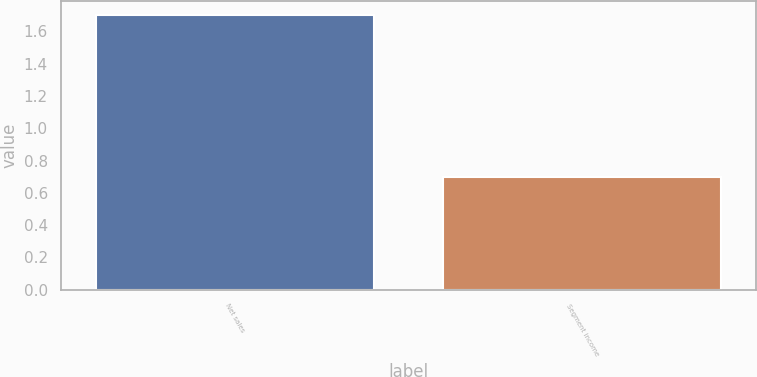<chart> <loc_0><loc_0><loc_500><loc_500><bar_chart><fcel>Net sales<fcel>Segment income<nl><fcel>1.7<fcel>0.7<nl></chart> 